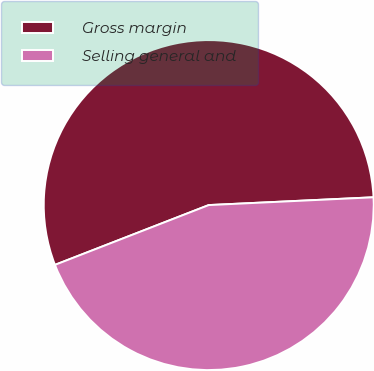Convert chart. <chart><loc_0><loc_0><loc_500><loc_500><pie_chart><fcel>Gross margin<fcel>Selling general and<nl><fcel>55.15%<fcel>44.85%<nl></chart> 